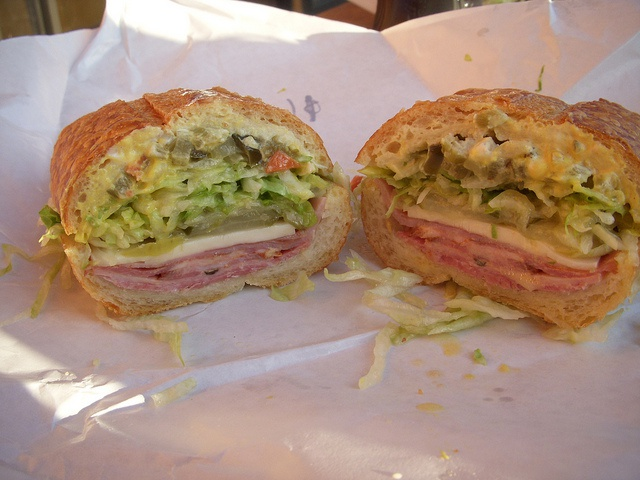Describe the objects in this image and their specific colors. I can see sandwich in black, tan, gray, brown, and olive tones and sandwich in black, brown, gray, tan, and olive tones in this image. 